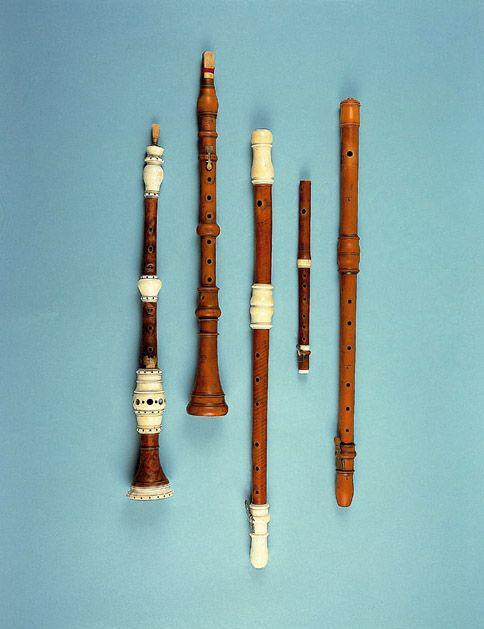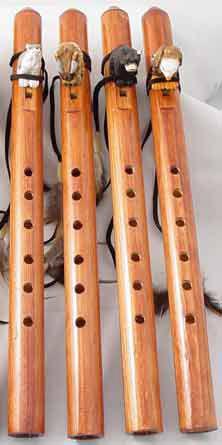The first image is the image on the left, the second image is the image on the right. Considering the images on both sides, is "The background of one of the images is blue." valid? Answer yes or no. Yes. The first image is the image on the left, the second image is the image on the right. Analyze the images presented: Is the assertion "One image contains exactly four wooden flutes displayed in a row, with cords at their tops." valid? Answer yes or no. Yes. 